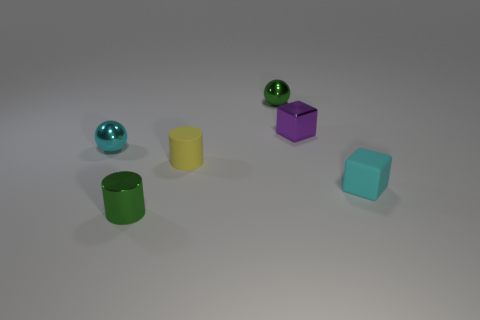Add 3 tiny purple metallic things. How many objects exist? 9 Subtract all blocks. How many objects are left? 4 Subtract all small rubber objects. Subtract all tiny rubber cubes. How many objects are left? 3 Add 4 tiny metallic cylinders. How many tiny metallic cylinders are left? 5 Add 1 tiny green objects. How many tiny green objects exist? 3 Subtract 0 brown balls. How many objects are left? 6 